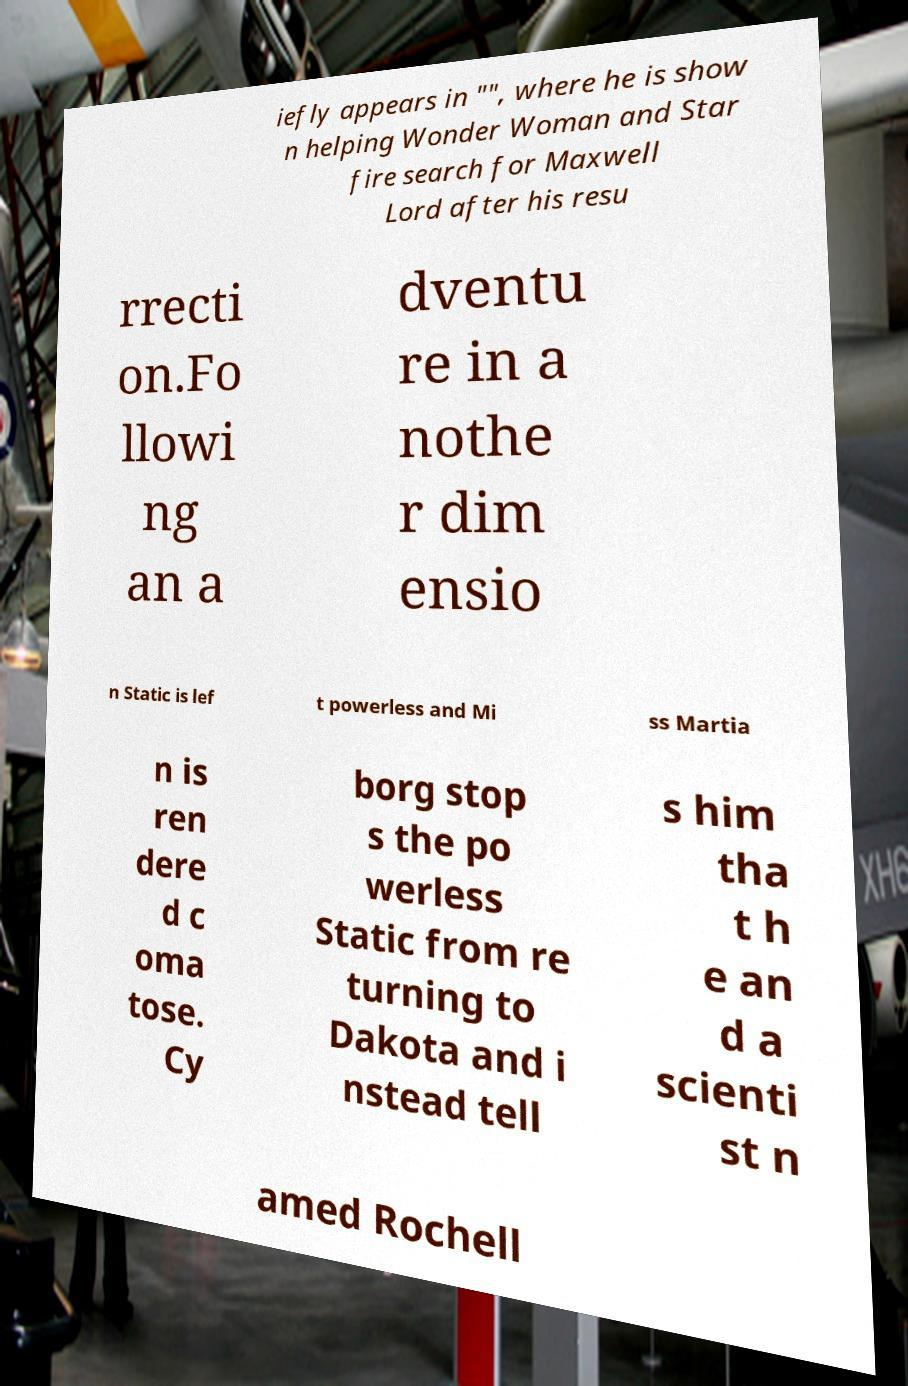What messages or text are displayed in this image? I need them in a readable, typed format. iefly appears in "", where he is show n helping Wonder Woman and Star fire search for Maxwell Lord after his resu rrecti on.Fo llowi ng an a dventu re in a nothe r dim ensio n Static is lef t powerless and Mi ss Martia n is ren dere d c oma tose. Cy borg stop s the po werless Static from re turning to Dakota and i nstead tell s him tha t h e an d a scienti st n amed Rochell 